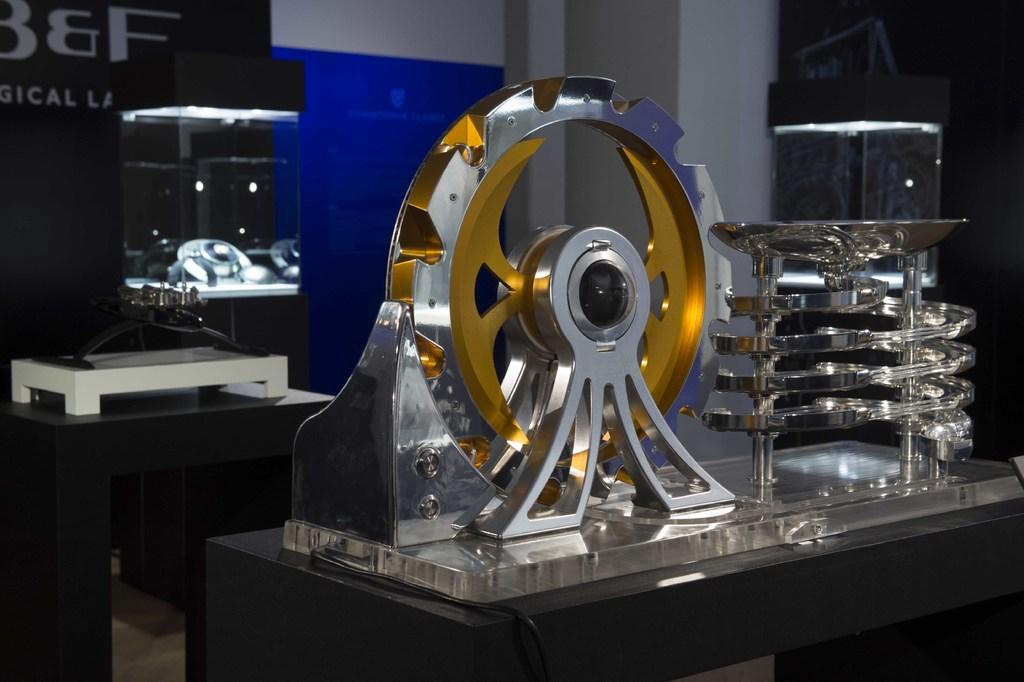What type of object is in the image? There is a metal gear in the image. What else can be seen in the image that is related to the metal gear? There is metal equipment in the image. Where are the metal gear and equipment located? Both the metal gear and equipment are on a table. What can be seen in the background of the image? There is a wall visible in the background of the image. What type of cheese is being twisted in the image? There is no cheese or twisting action present in the image. 